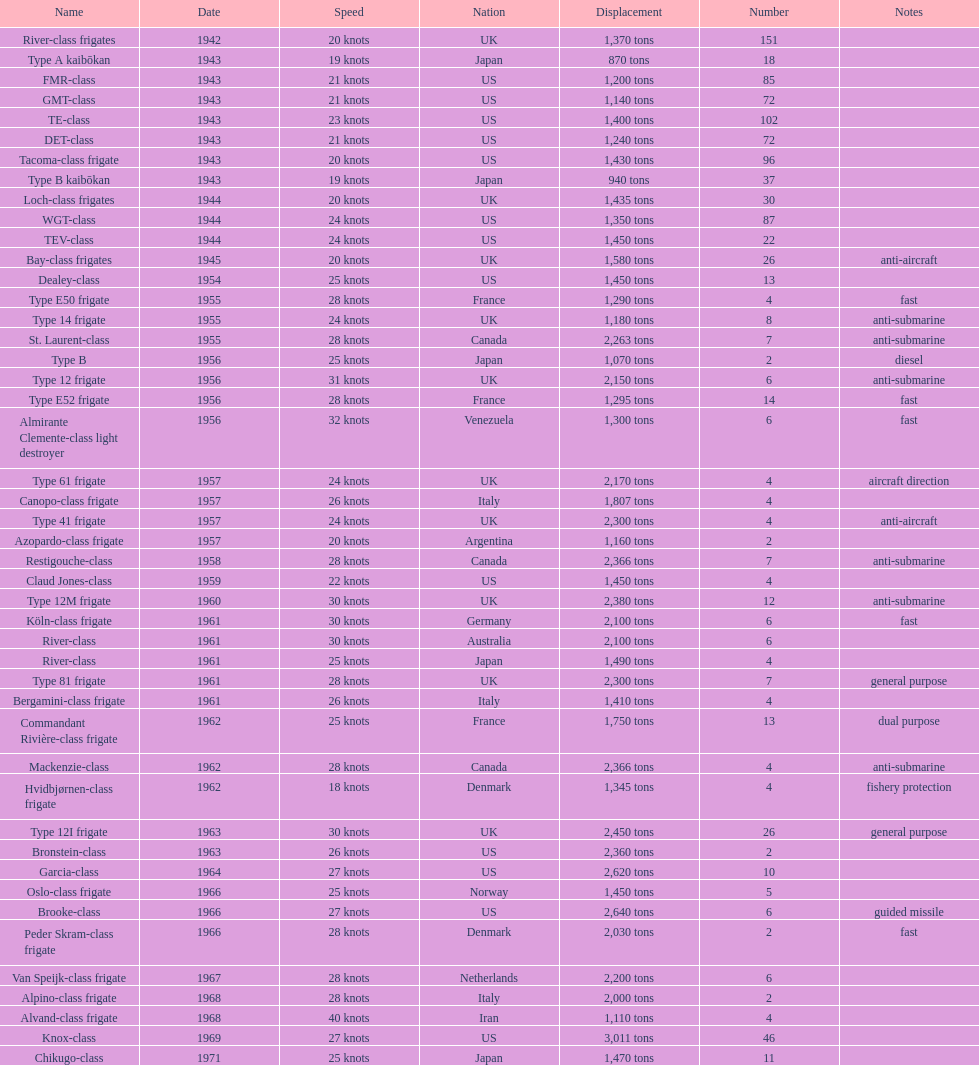How many tons does the te-class displace? 1,400 tons. 